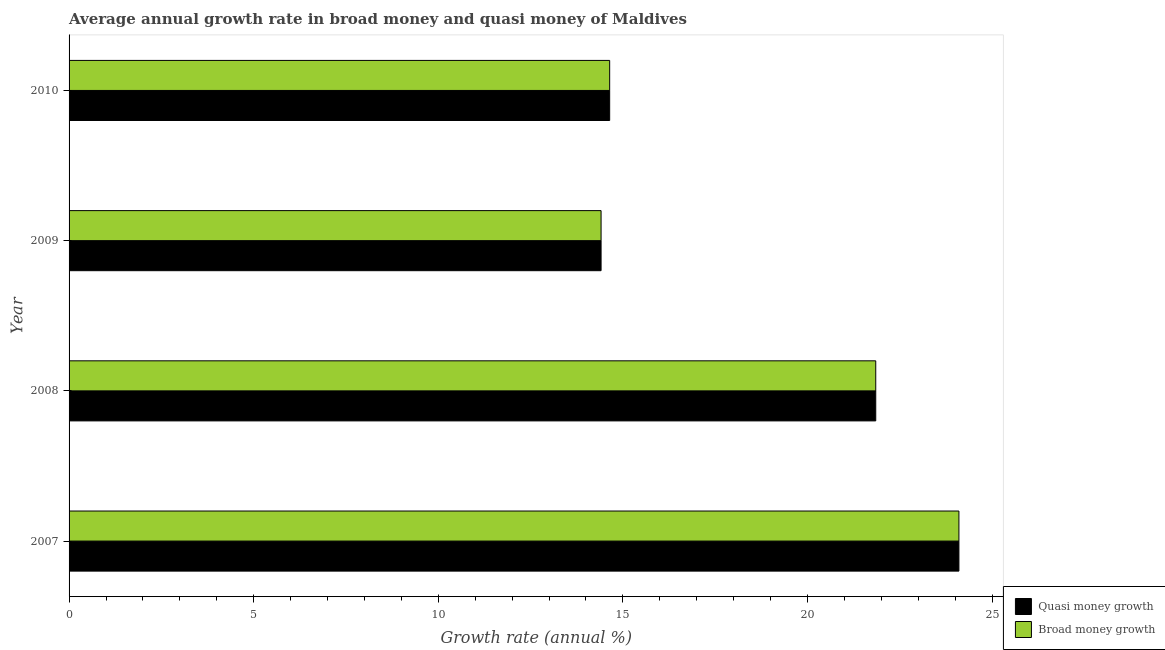How many different coloured bars are there?
Provide a short and direct response. 2. Are the number of bars on each tick of the Y-axis equal?
Provide a succinct answer. Yes. How many bars are there on the 4th tick from the bottom?
Make the answer very short. 2. What is the annual growth rate in broad money in 2010?
Make the answer very short. 14.64. Across all years, what is the maximum annual growth rate in broad money?
Offer a terse response. 24.1. Across all years, what is the minimum annual growth rate in quasi money?
Provide a short and direct response. 14.41. In which year was the annual growth rate in quasi money maximum?
Your response must be concise. 2007. What is the total annual growth rate in quasi money in the graph?
Ensure brevity in your answer.  75. What is the difference between the annual growth rate in broad money in 2007 and that in 2008?
Keep it short and to the point. 2.25. What is the difference between the annual growth rate in quasi money in 2008 and the annual growth rate in broad money in 2009?
Make the answer very short. 7.44. What is the average annual growth rate in quasi money per year?
Make the answer very short. 18.75. In the year 2010, what is the difference between the annual growth rate in quasi money and annual growth rate in broad money?
Your response must be concise. 0. In how many years, is the annual growth rate in broad money greater than 3 %?
Provide a short and direct response. 4. What is the ratio of the annual growth rate in broad money in 2007 to that in 2008?
Your response must be concise. 1.1. Is the difference between the annual growth rate in quasi money in 2008 and 2010 greater than the difference between the annual growth rate in broad money in 2008 and 2010?
Your answer should be very brief. No. What is the difference between the highest and the second highest annual growth rate in broad money?
Your response must be concise. 2.25. What is the difference between the highest and the lowest annual growth rate in quasi money?
Make the answer very short. 9.69. What does the 1st bar from the top in 2007 represents?
Offer a terse response. Broad money growth. What does the 1st bar from the bottom in 2008 represents?
Offer a very short reply. Quasi money growth. What is the difference between two consecutive major ticks on the X-axis?
Offer a very short reply. 5. Does the graph contain any zero values?
Keep it short and to the point. No. What is the title of the graph?
Offer a very short reply. Average annual growth rate in broad money and quasi money of Maldives. What is the label or title of the X-axis?
Your response must be concise. Growth rate (annual %). What is the Growth rate (annual %) of Quasi money growth in 2007?
Offer a terse response. 24.1. What is the Growth rate (annual %) in Broad money growth in 2007?
Offer a very short reply. 24.1. What is the Growth rate (annual %) of Quasi money growth in 2008?
Your answer should be compact. 21.85. What is the Growth rate (annual %) in Broad money growth in 2008?
Your answer should be very brief. 21.85. What is the Growth rate (annual %) in Quasi money growth in 2009?
Your answer should be compact. 14.41. What is the Growth rate (annual %) in Broad money growth in 2009?
Give a very brief answer. 14.41. What is the Growth rate (annual %) of Quasi money growth in 2010?
Offer a terse response. 14.64. What is the Growth rate (annual %) of Broad money growth in 2010?
Offer a terse response. 14.64. Across all years, what is the maximum Growth rate (annual %) in Quasi money growth?
Offer a very short reply. 24.1. Across all years, what is the maximum Growth rate (annual %) in Broad money growth?
Ensure brevity in your answer.  24.1. Across all years, what is the minimum Growth rate (annual %) in Quasi money growth?
Your response must be concise. 14.41. Across all years, what is the minimum Growth rate (annual %) in Broad money growth?
Offer a terse response. 14.41. What is the total Growth rate (annual %) in Quasi money growth in the graph?
Provide a succinct answer. 75. What is the total Growth rate (annual %) of Broad money growth in the graph?
Make the answer very short. 75. What is the difference between the Growth rate (annual %) in Quasi money growth in 2007 and that in 2008?
Give a very brief answer. 2.25. What is the difference between the Growth rate (annual %) in Broad money growth in 2007 and that in 2008?
Your answer should be compact. 2.25. What is the difference between the Growth rate (annual %) in Quasi money growth in 2007 and that in 2009?
Give a very brief answer. 9.69. What is the difference between the Growth rate (annual %) of Broad money growth in 2007 and that in 2009?
Your response must be concise. 9.69. What is the difference between the Growth rate (annual %) of Quasi money growth in 2007 and that in 2010?
Offer a very short reply. 9.46. What is the difference between the Growth rate (annual %) in Broad money growth in 2007 and that in 2010?
Provide a short and direct response. 9.46. What is the difference between the Growth rate (annual %) in Quasi money growth in 2008 and that in 2009?
Keep it short and to the point. 7.44. What is the difference between the Growth rate (annual %) in Broad money growth in 2008 and that in 2009?
Offer a very short reply. 7.44. What is the difference between the Growth rate (annual %) in Quasi money growth in 2008 and that in 2010?
Offer a very short reply. 7.21. What is the difference between the Growth rate (annual %) in Broad money growth in 2008 and that in 2010?
Your response must be concise. 7.21. What is the difference between the Growth rate (annual %) of Quasi money growth in 2009 and that in 2010?
Offer a very short reply. -0.23. What is the difference between the Growth rate (annual %) in Broad money growth in 2009 and that in 2010?
Offer a terse response. -0.23. What is the difference between the Growth rate (annual %) in Quasi money growth in 2007 and the Growth rate (annual %) in Broad money growth in 2008?
Offer a terse response. 2.25. What is the difference between the Growth rate (annual %) of Quasi money growth in 2007 and the Growth rate (annual %) of Broad money growth in 2009?
Keep it short and to the point. 9.69. What is the difference between the Growth rate (annual %) of Quasi money growth in 2007 and the Growth rate (annual %) of Broad money growth in 2010?
Offer a terse response. 9.46. What is the difference between the Growth rate (annual %) of Quasi money growth in 2008 and the Growth rate (annual %) of Broad money growth in 2009?
Make the answer very short. 7.44. What is the difference between the Growth rate (annual %) of Quasi money growth in 2008 and the Growth rate (annual %) of Broad money growth in 2010?
Your answer should be compact. 7.21. What is the difference between the Growth rate (annual %) in Quasi money growth in 2009 and the Growth rate (annual %) in Broad money growth in 2010?
Ensure brevity in your answer.  -0.23. What is the average Growth rate (annual %) of Quasi money growth per year?
Your answer should be very brief. 18.75. What is the average Growth rate (annual %) of Broad money growth per year?
Offer a very short reply. 18.75. In the year 2007, what is the difference between the Growth rate (annual %) of Quasi money growth and Growth rate (annual %) of Broad money growth?
Provide a short and direct response. 0. In the year 2008, what is the difference between the Growth rate (annual %) of Quasi money growth and Growth rate (annual %) of Broad money growth?
Give a very brief answer. 0. What is the ratio of the Growth rate (annual %) of Quasi money growth in 2007 to that in 2008?
Offer a very short reply. 1.1. What is the ratio of the Growth rate (annual %) in Broad money growth in 2007 to that in 2008?
Make the answer very short. 1.1. What is the ratio of the Growth rate (annual %) of Quasi money growth in 2007 to that in 2009?
Make the answer very short. 1.67. What is the ratio of the Growth rate (annual %) of Broad money growth in 2007 to that in 2009?
Offer a very short reply. 1.67. What is the ratio of the Growth rate (annual %) of Quasi money growth in 2007 to that in 2010?
Your answer should be very brief. 1.65. What is the ratio of the Growth rate (annual %) in Broad money growth in 2007 to that in 2010?
Give a very brief answer. 1.65. What is the ratio of the Growth rate (annual %) of Quasi money growth in 2008 to that in 2009?
Make the answer very short. 1.52. What is the ratio of the Growth rate (annual %) in Broad money growth in 2008 to that in 2009?
Ensure brevity in your answer.  1.52. What is the ratio of the Growth rate (annual %) of Quasi money growth in 2008 to that in 2010?
Provide a succinct answer. 1.49. What is the ratio of the Growth rate (annual %) in Broad money growth in 2008 to that in 2010?
Your answer should be very brief. 1.49. What is the ratio of the Growth rate (annual %) in Quasi money growth in 2009 to that in 2010?
Your answer should be very brief. 0.98. What is the ratio of the Growth rate (annual %) in Broad money growth in 2009 to that in 2010?
Your answer should be very brief. 0.98. What is the difference between the highest and the second highest Growth rate (annual %) in Quasi money growth?
Offer a terse response. 2.25. What is the difference between the highest and the second highest Growth rate (annual %) of Broad money growth?
Your response must be concise. 2.25. What is the difference between the highest and the lowest Growth rate (annual %) in Quasi money growth?
Offer a very short reply. 9.69. What is the difference between the highest and the lowest Growth rate (annual %) of Broad money growth?
Keep it short and to the point. 9.69. 